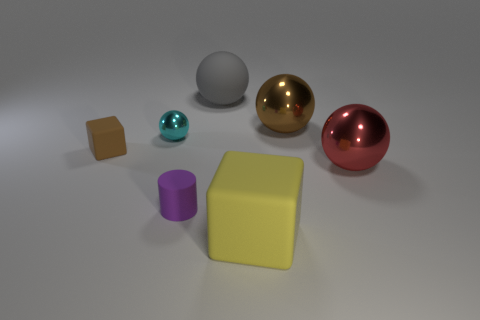Is there anything else of the same color as the large rubber cube?
Ensure brevity in your answer.  No. What is the size of the rubber thing that is behind the metallic object that is to the left of the big brown metal sphere?
Your answer should be compact. Large. What is the color of the rubber thing that is both to the right of the tiny cube and behind the red shiny thing?
Give a very brief answer. Gray. What number of other objects are the same size as the red thing?
Your answer should be very brief. 3. Does the gray matte sphere have the same size as the matte block that is on the left side of the yellow thing?
Give a very brief answer. No. What color is the matte sphere that is the same size as the red thing?
Your response must be concise. Gray. The brown shiny ball is what size?
Offer a very short reply. Large. Is the cube that is on the right side of the brown rubber object made of the same material as the tiny cyan ball?
Your response must be concise. No. Is the shape of the big red metal object the same as the big brown metal thing?
Provide a succinct answer. Yes. There is a brown thing that is behind the rubber block that is on the left side of the small thing that is in front of the tiny brown rubber cube; what is its shape?
Your answer should be very brief. Sphere. 